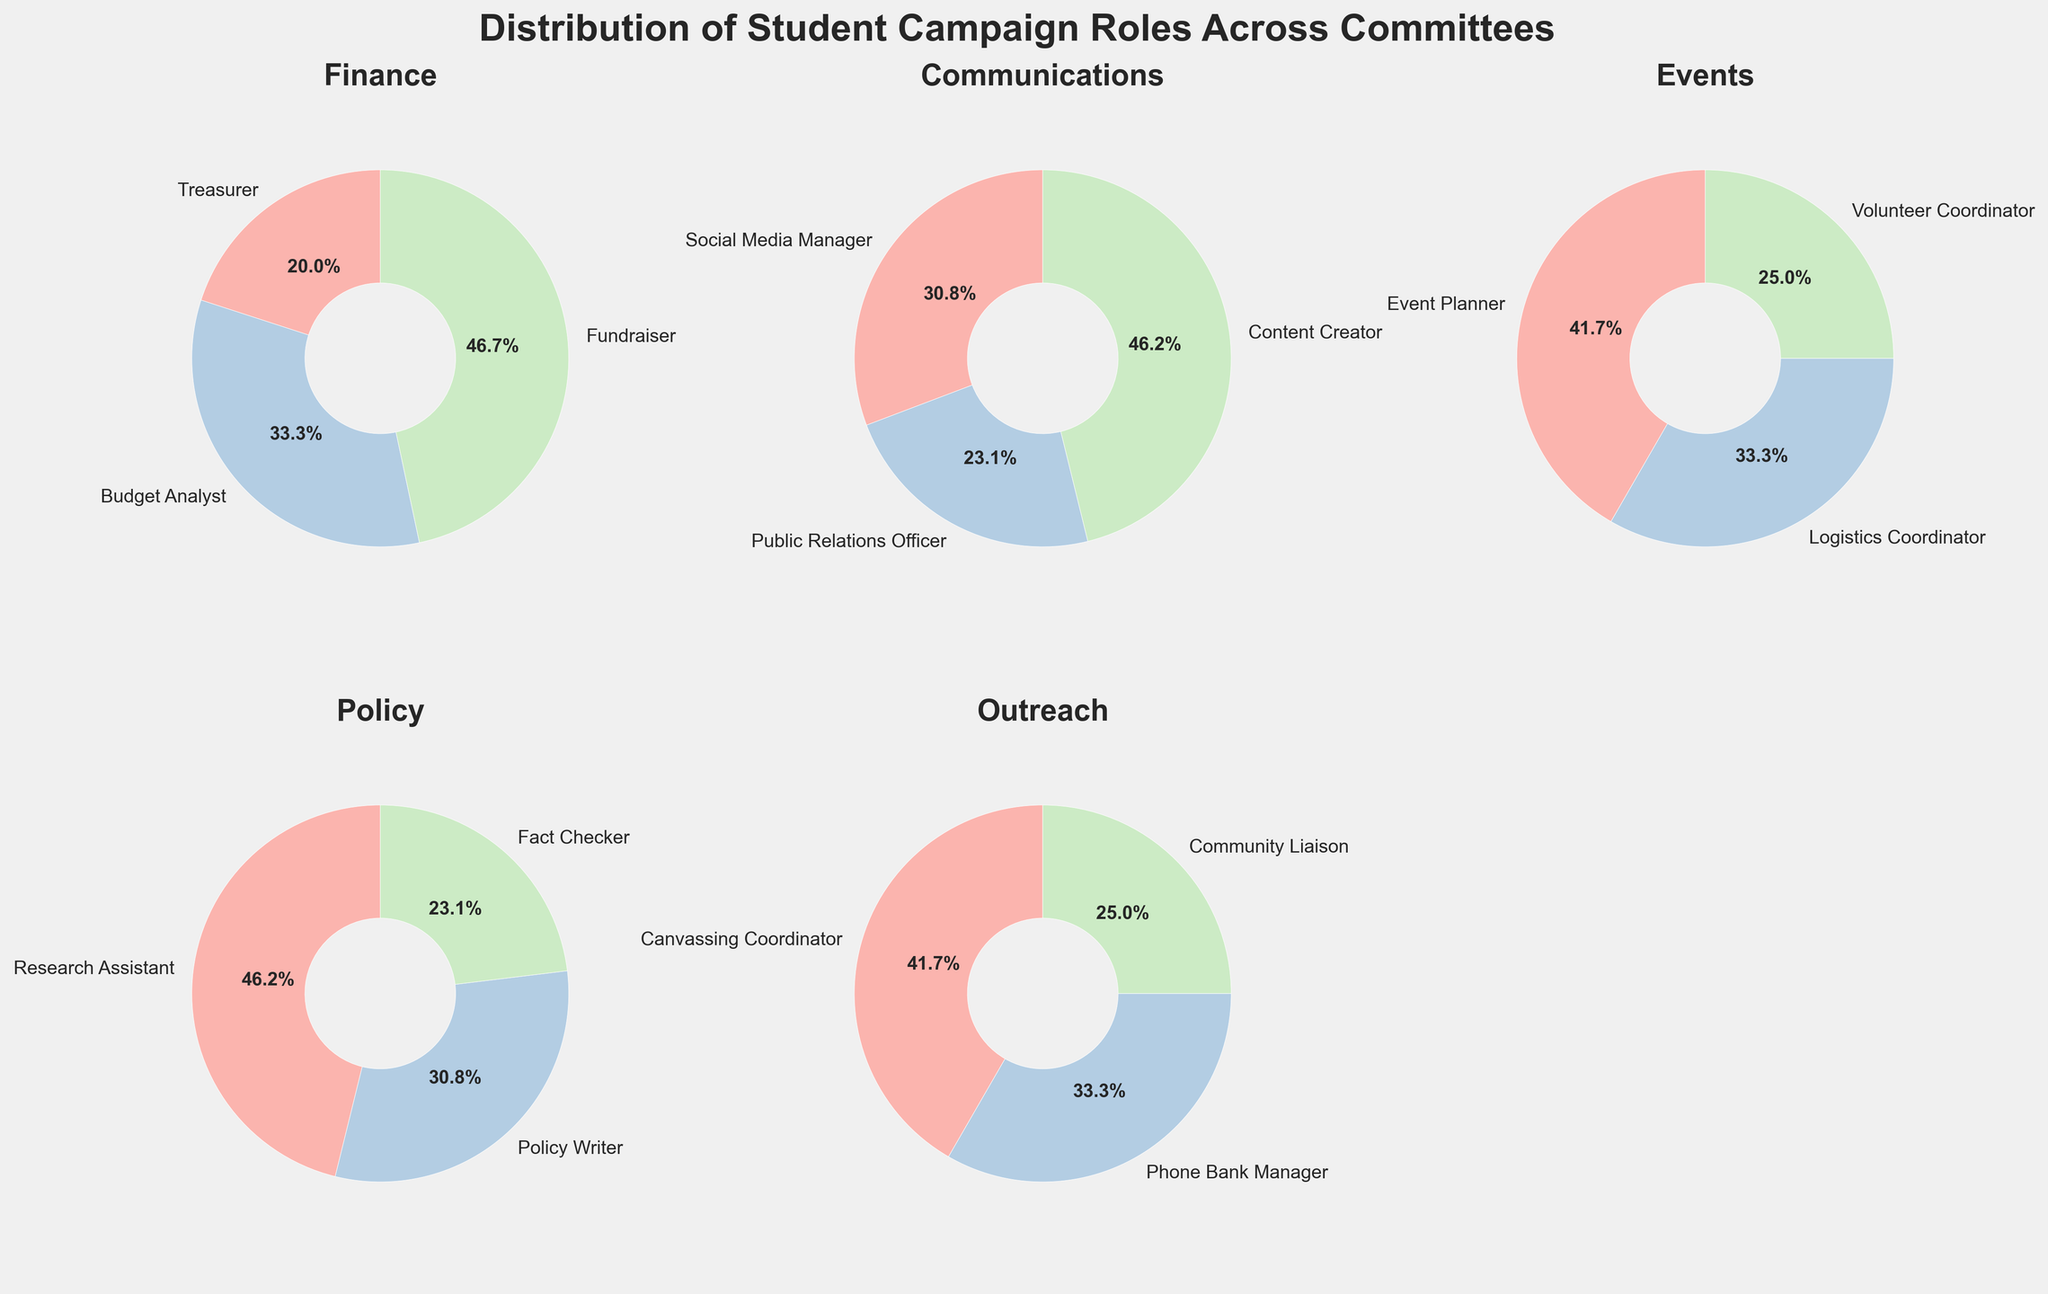Which committee has the highest number of roles? Looking at the figure, we see the Finance committee has 3 roles (Treasurer, Budget Analyst, Fundraiser), which is equal to the highest number of roles among other committees listed.
Answer: Finance Which committee has the most evenly distributed roles? By examining the pie charts, the Policy committee has three nearly equal sections (Research Assistant, Policy Writer, Fact Checker), indicating an even distribution of roles.
Answer: Policy What percentage of roles in the Finance committee is occupied by Fundraisers? In the pie chart for Finance, Fundraisers take up roughly one-third. Since there are 15 roles in Finance, Fundraisers comprise around 46.7%.
Answer: 46.7% Compare the largest section in the Events committee with the largest section in the Outreach committee. Which role is more prevalent? By comparing, Event Planner in the Events committee and Canvassing Coordinator in Outreach both take up the largest sections. Since Event Planner has 5 and Canvassing Coordinator has 5 roles, they are equal.
Answer: Equal Which committee has the smallest section compared to others? The smallest section in the pie charts is the Community Liaison in the Outreach committee, which roughly occupies the smallest portion of the chart.
Answer: Community Liaison in Outreach What is the total number of roles in the Communications committee? Adding the roles, Social Media Manager (4), Public Relations Officer (3), and Content Creator (6) gives a total of 4+3+6 = 13.
Answer: 13 How does the number of Logistical Coordinators in the Events committee compare to Fact Checkers in the Policy committee? The Events committee has 4 Logistical Coordinators, while the Policy committee has 3 Fact Checkers, showing there are more Logistics Coordinators.
Answer: More Which role in the Finance committee has the least number of students, and how many are there? In the Finance committee pie chart, the Treasurer has the least number of students, which is 3.
Answer: Treasurer, 3 Which committees' largest roles are exactly the same in number, and what is that number? The Events and Outreach committees both have their largest roles, Event Planner and Canvassing Coordinator respectively, at 5 roles.
Answer: Events and Outreach, 5 